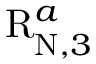<formula> <loc_0><loc_0><loc_500><loc_500>R _ { N , 3 } ^ { a }</formula> 